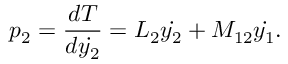<formula> <loc_0><loc_0><loc_500><loc_500>p _ { 2 } = \frac { d T } { d \dot { y _ { 2 } } } = L _ { 2 } \dot { y _ { 2 } } + M _ { 1 2 } \dot { y _ { 1 } } .</formula> 